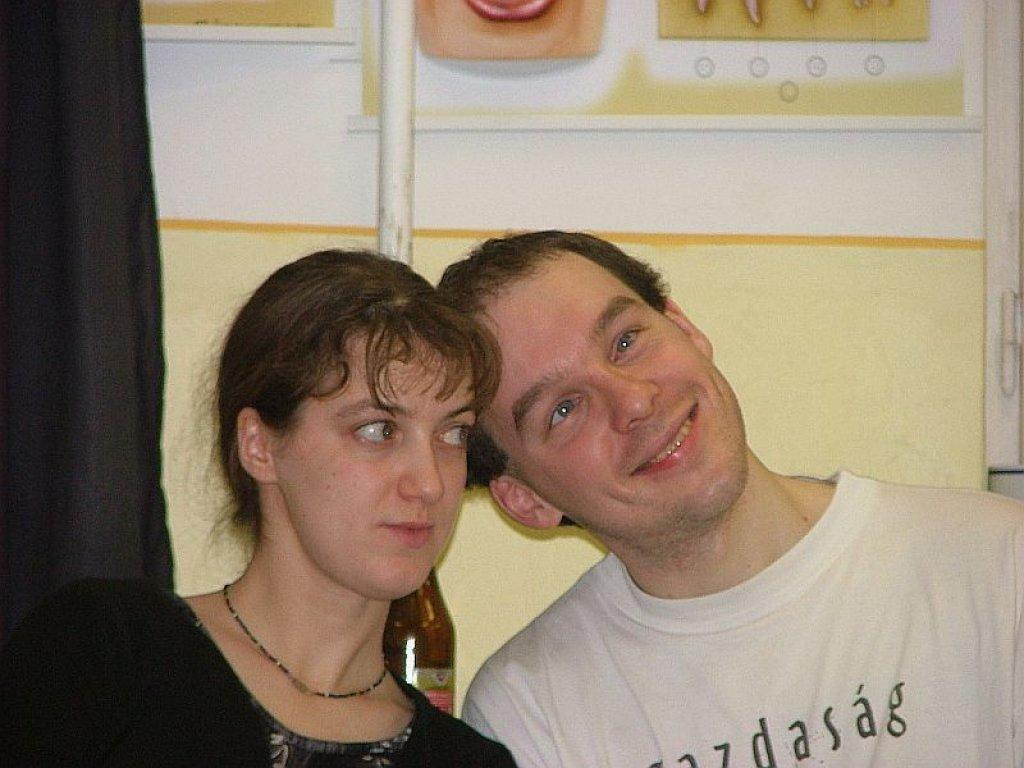How many people are in the image? There are persons in the image, but the exact number is not specified. What is behind the persons in the image? The persons are in front of a wall. What is at the top of the image? There is a pole at the top of the image. What is on the left side of the image? There is a curtain on the left side of the image. Are the persons in the image on vacation? There is no information about the persons' activities or intentions in the image, so it cannot be determined if they are on vacation. 